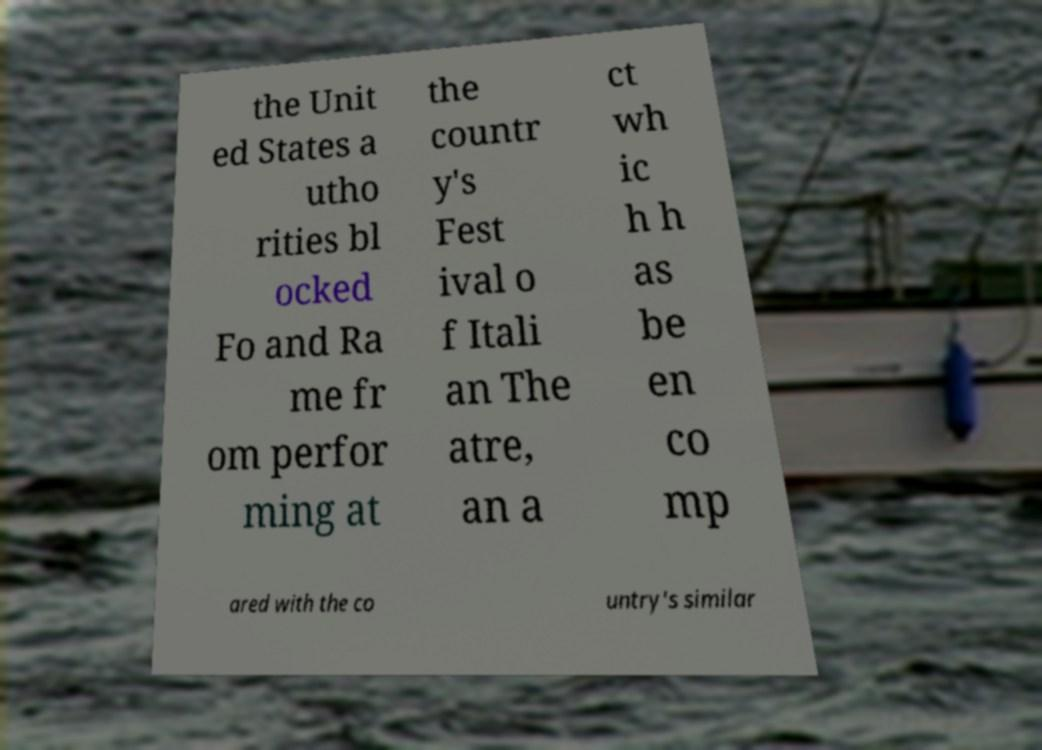For documentation purposes, I need the text within this image transcribed. Could you provide that? the Unit ed States a utho rities bl ocked Fo and Ra me fr om perfor ming at the countr y's Fest ival o f Itali an The atre, an a ct wh ic h h as be en co mp ared with the co untry's similar 